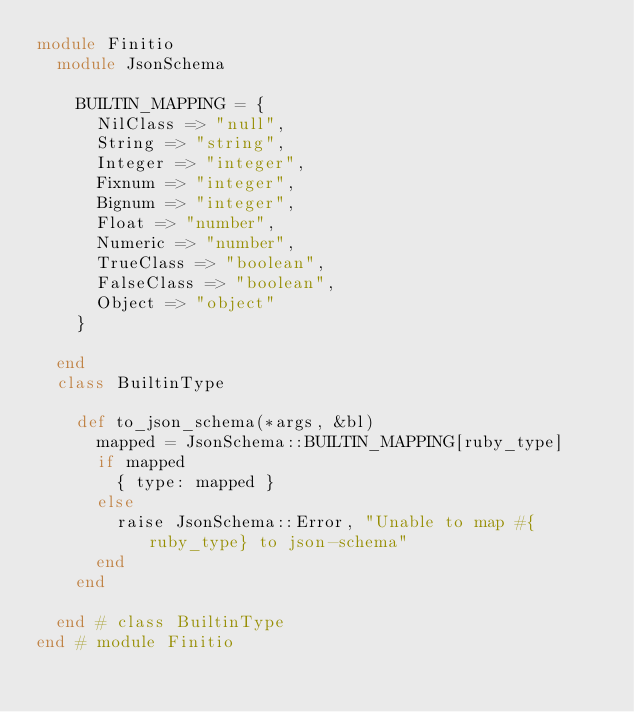Convert code to text. <code><loc_0><loc_0><loc_500><loc_500><_Ruby_>module Finitio
  module JsonSchema

    BUILTIN_MAPPING = {
      NilClass => "null",
      String => "string",
      Integer => "integer",
      Fixnum => "integer",
      Bignum => "integer",
      Float => "number",
      Numeric => "number",
      TrueClass => "boolean",
      FalseClass => "boolean",
      Object => "object"
    }

  end
  class BuiltinType

    def to_json_schema(*args, &bl)
      mapped = JsonSchema::BUILTIN_MAPPING[ruby_type]
      if mapped
        { type: mapped }
      else
        raise JsonSchema::Error, "Unable to map #{ruby_type} to json-schema"
      end
    end

  end # class BuiltinType
end # module Finitio
</code> 